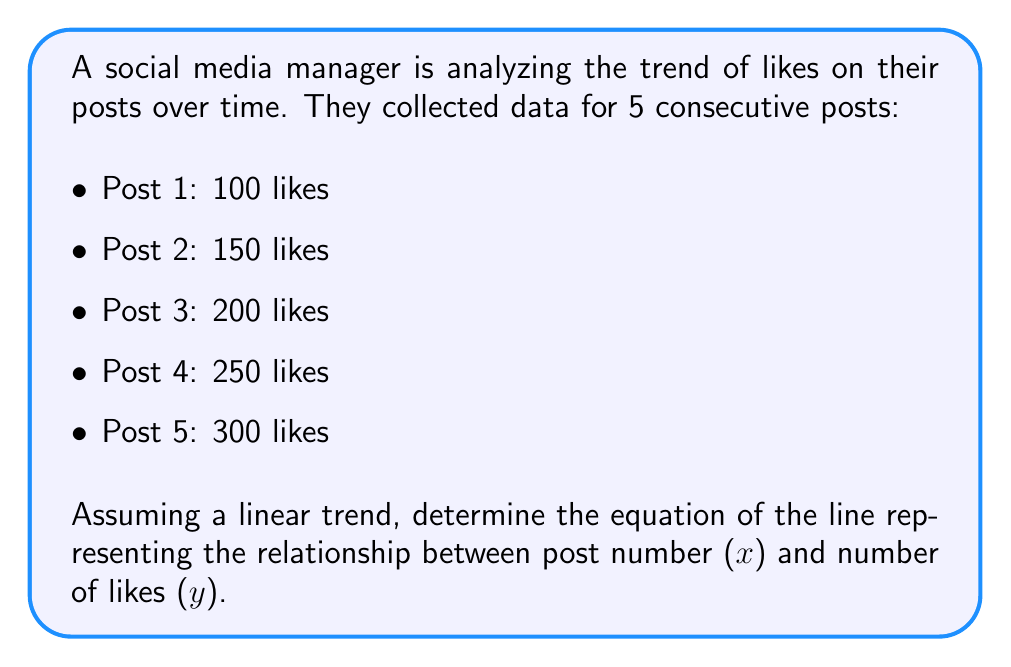Teach me how to tackle this problem. To find the equation of the line, we'll use the point-slope form: $y - y_1 = m(x - x_1)$, where $m$ is the slope and $(x_1, y_1)$ is a point on the line.

Step 1: Calculate the slope (m)
We can use any two points to calculate the slope. Let's use the first and last points:
$m = \frac{y_2 - y_1}{x_2 - x_1} = \frac{300 - 100}{5 - 1} = \frac{200}{4} = 50$

Step 2: Choose a point to use in the equation
We can use any point. Let's use the first point: (1, 100)

Step 3: Substitute the values into the point-slope form
$y - 100 = 50(x - 1)$

Step 4: Simplify to get the slope-intercept form $(y = mx + b)$
$y - 100 = 50x - 50$
$y = 50x - 50 + 100$
$y = 50x + 50$

Therefore, the equation of the line representing the trend in social media engagement is $y = 50x + 50$, where $x$ is the post number and $y$ is the number of likes.
Answer: $y = 50x + 50$ 